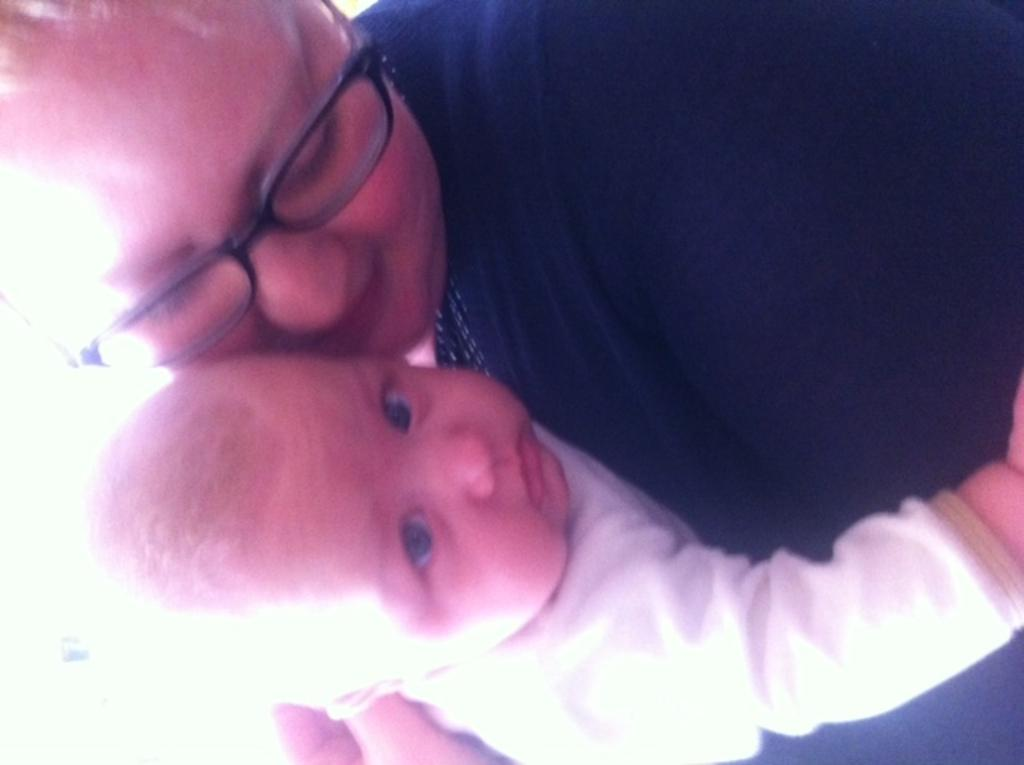How many people are in the image? There are two persons in the image. Can you describe the appearance of the persons in the image? Both persons are truncated. What is one of the persons wearing? One of the persons is wearing spectacles. What type of string is being used for distribution in the image? There is no string or distribution activity present in the image. Can you tell me how many basketballs are visible in the image? There are no basketballs present in the image. 